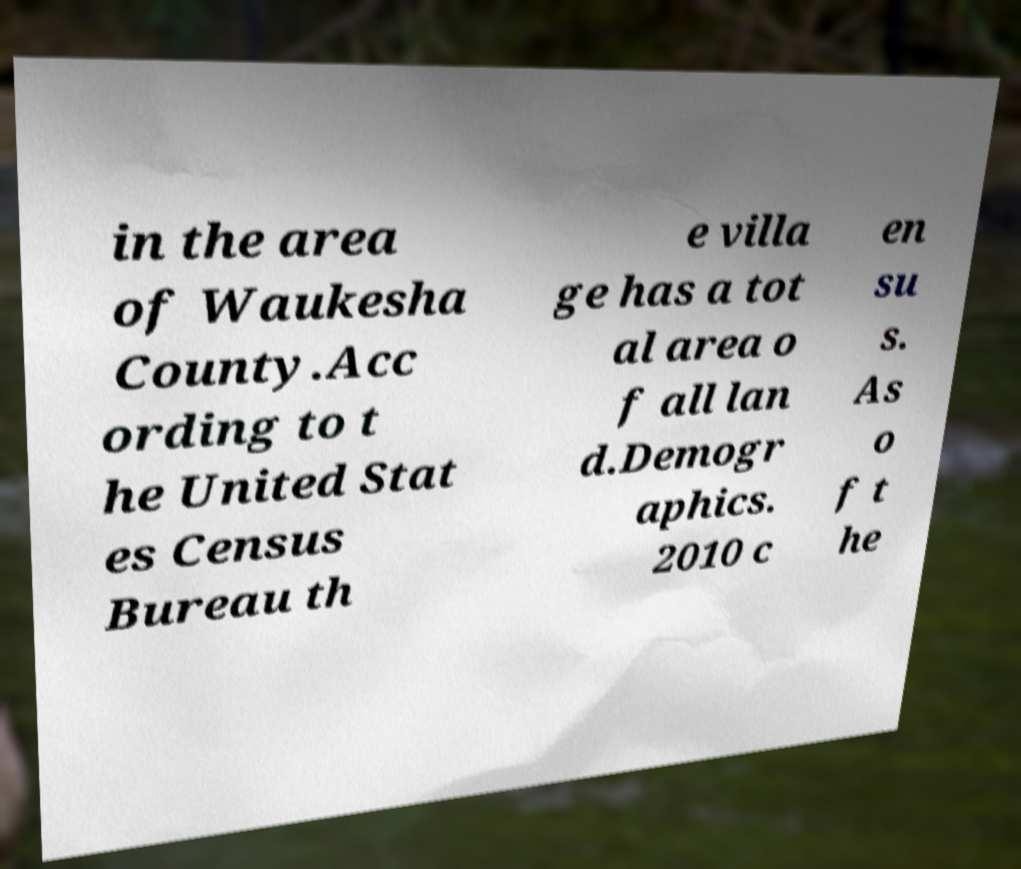Could you assist in decoding the text presented in this image and type it out clearly? in the area of Waukesha County.Acc ording to t he United Stat es Census Bureau th e villa ge has a tot al area o f all lan d.Demogr aphics. 2010 c en su s. As o f t he 